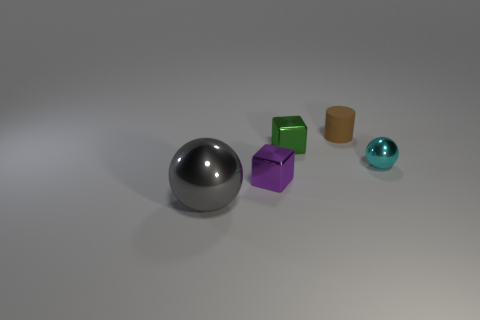What shape is the tiny cyan thing that is made of the same material as the gray ball?
Offer a terse response. Sphere. Is there anything else that has the same shape as the gray shiny object?
Keep it short and to the point. Yes. Is the object that is on the right side of the small rubber cylinder made of the same material as the gray ball?
Your answer should be compact. Yes. There is a ball to the left of the small brown matte thing; what is its material?
Keep it short and to the point. Metal. There is a object that is to the left of the tiny metallic object that is in front of the tiny metal ball; what size is it?
Offer a terse response. Large. What number of green metal objects are the same size as the brown matte object?
Offer a very short reply. 1. There is a tiny metal block that is behind the cyan shiny thing; is it the same color as the sphere on the left side of the purple metal thing?
Make the answer very short. No. Are there any green blocks behind the large ball?
Provide a short and direct response. Yes. There is a small thing that is both right of the tiny green shiny block and in front of the brown cylinder; what color is it?
Give a very brief answer. Cyan. Are there any tiny cubes that have the same color as the rubber thing?
Your answer should be very brief. No. 